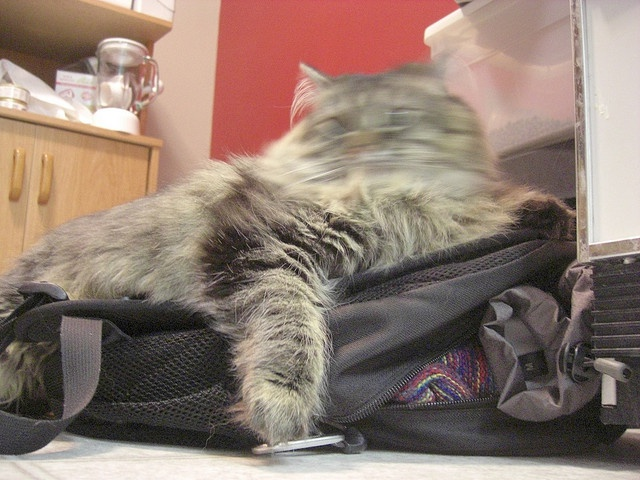Describe the objects in this image and their specific colors. I can see cat in brown, darkgray, gray, and tan tones and backpack in gray and black tones in this image. 